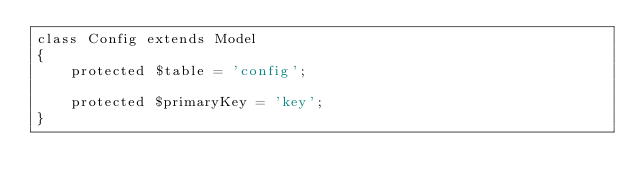Convert code to text. <code><loc_0><loc_0><loc_500><loc_500><_PHP_>class Config extends Model
{
    protected $table = 'config';

    protected $primaryKey = 'key';
}</code> 